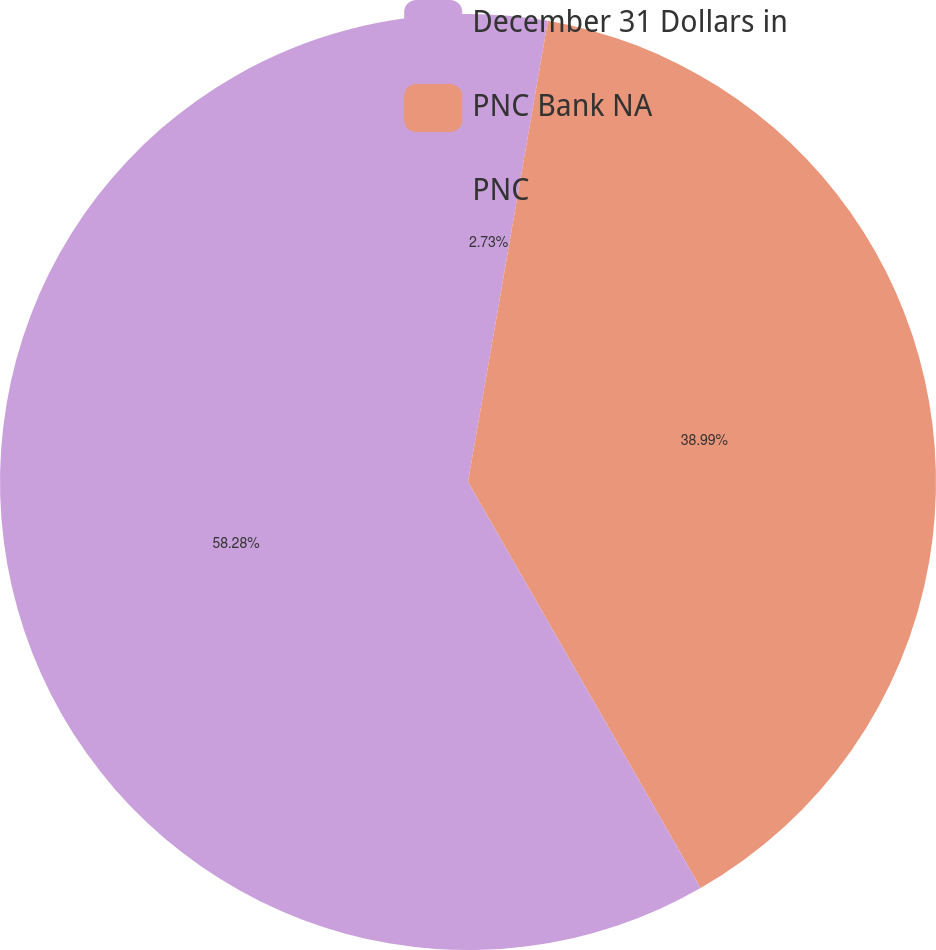<chart> <loc_0><loc_0><loc_500><loc_500><pie_chart><fcel>December 31 Dollars in<fcel>PNC Bank NA<fcel>PNC<nl><fcel>2.73%<fcel>38.99%<fcel>58.28%<nl></chart> 